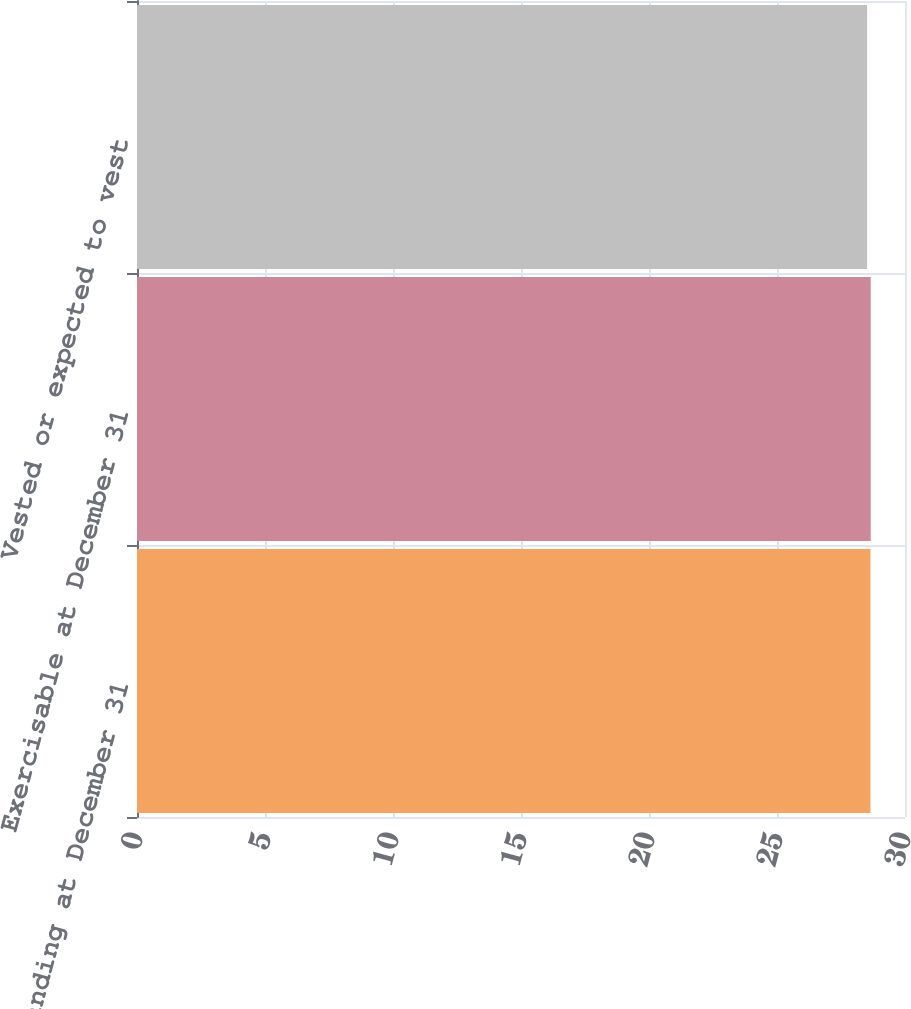Convert chart to OTSL. <chart><loc_0><loc_0><loc_500><loc_500><bar_chart><fcel>Outstanding at December 31<fcel>Exercisable at December 31<fcel>Vested or expected to vest<nl><fcel>28.65<fcel>28.66<fcel>28.52<nl></chart> 